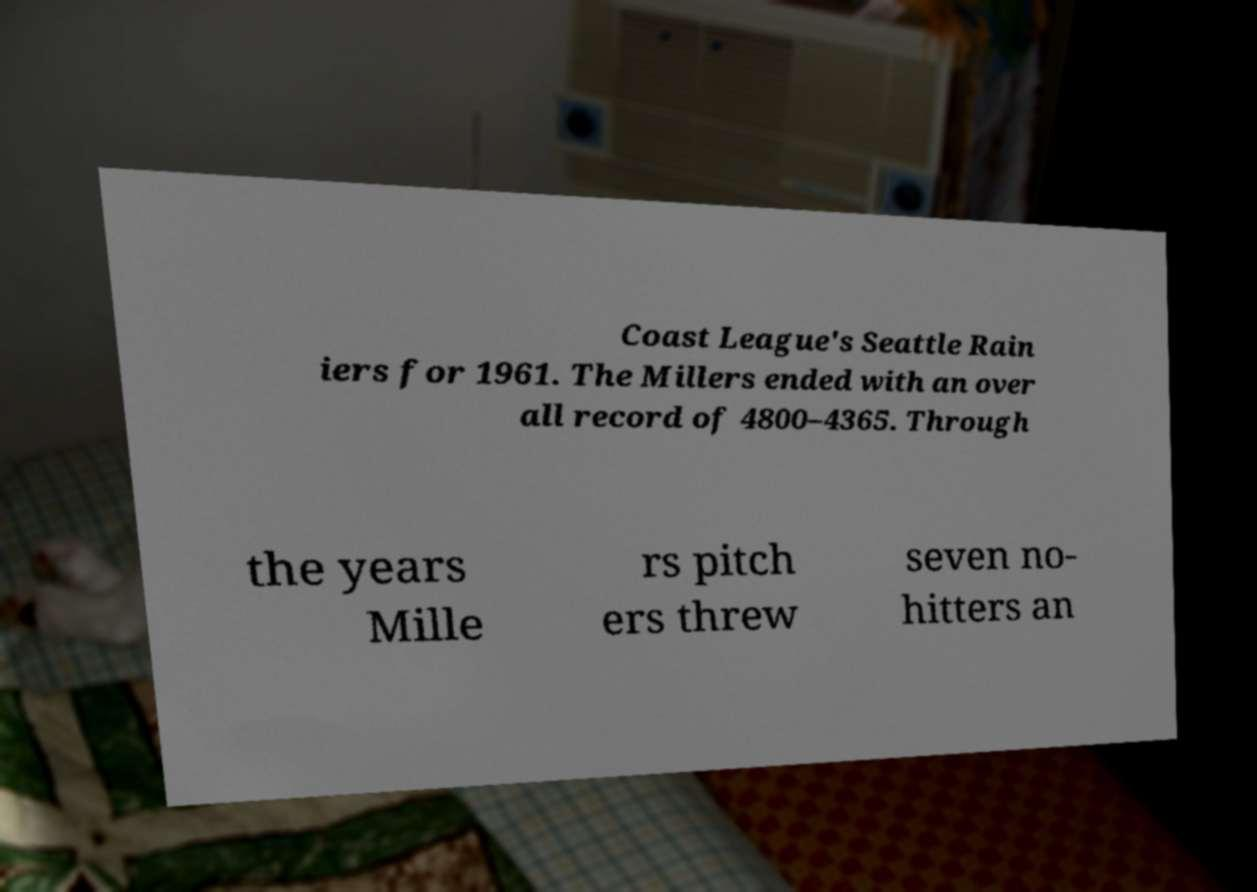There's text embedded in this image that I need extracted. Can you transcribe it verbatim? Coast League's Seattle Rain iers for 1961. The Millers ended with an over all record of 4800–4365. Through the years Mille rs pitch ers threw seven no- hitters an 